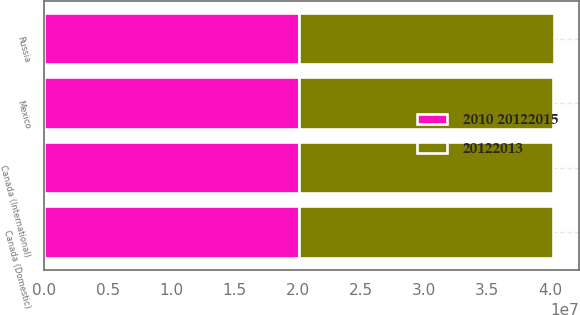<chart> <loc_0><loc_0><loc_500><loc_500><stacked_bar_chart><ecel><fcel>Mexico<fcel>Canada (Domestic)<fcel>Canada (International)<fcel>Russia<nl><fcel>20122013<fcel>2.0112e+07<fcel>2.0112e+07<fcel>2.0092e+07<fcel>2.0122e+07<nl><fcel>2010 20122015<fcel>2.0112e+07<fcel>2.0112e+07<fcel>2.0102e+07<fcel>2.0132e+07<nl></chart> 